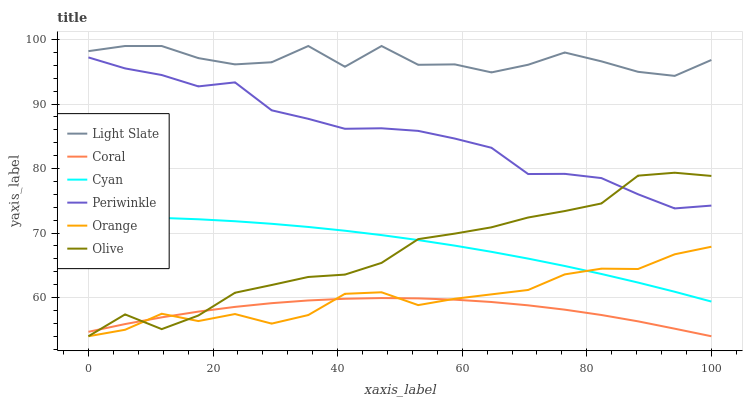Does Coral have the minimum area under the curve?
Answer yes or no. Yes. Does Light Slate have the maximum area under the curve?
Answer yes or no. Yes. Does Olive have the minimum area under the curve?
Answer yes or no. No. Does Olive have the maximum area under the curve?
Answer yes or no. No. Is Cyan the smoothest?
Answer yes or no. Yes. Is Light Slate the roughest?
Answer yes or no. Yes. Is Coral the smoothest?
Answer yes or no. No. Is Coral the roughest?
Answer yes or no. No. Does Periwinkle have the lowest value?
Answer yes or no. No. Does Olive have the highest value?
Answer yes or no. No. Is Cyan less than Light Slate?
Answer yes or no. Yes. Is Light Slate greater than Orange?
Answer yes or no. Yes. Does Cyan intersect Light Slate?
Answer yes or no. No. 